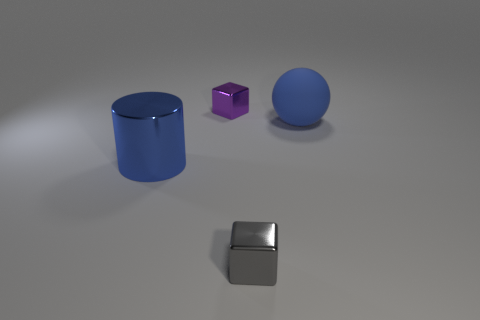Add 4 big blue rubber balls. How many objects exist? 8 Subtract all balls. How many objects are left? 3 Subtract 0 red cylinders. How many objects are left? 4 Subtract all blue cylinders. Subtract all shiny cylinders. How many objects are left? 2 Add 4 blue spheres. How many blue spheres are left? 5 Add 4 tiny objects. How many tiny objects exist? 6 